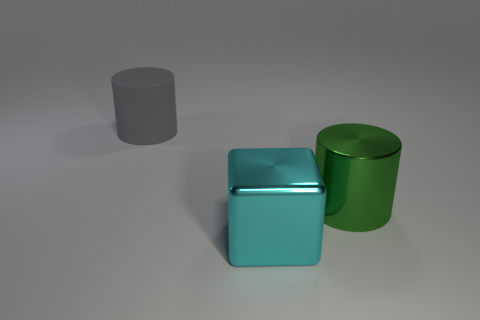Add 1 big brown metallic objects. How many objects exist? 4 Subtract all cylinders. How many objects are left? 1 Add 1 large yellow matte balls. How many large yellow matte balls exist? 1 Subtract 0 cyan balls. How many objects are left? 3 Subtract all big matte things. Subtract all gray rubber objects. How many objects are left? 1 Add 1 shiny blocks. How many shiny blocks are left? 2 